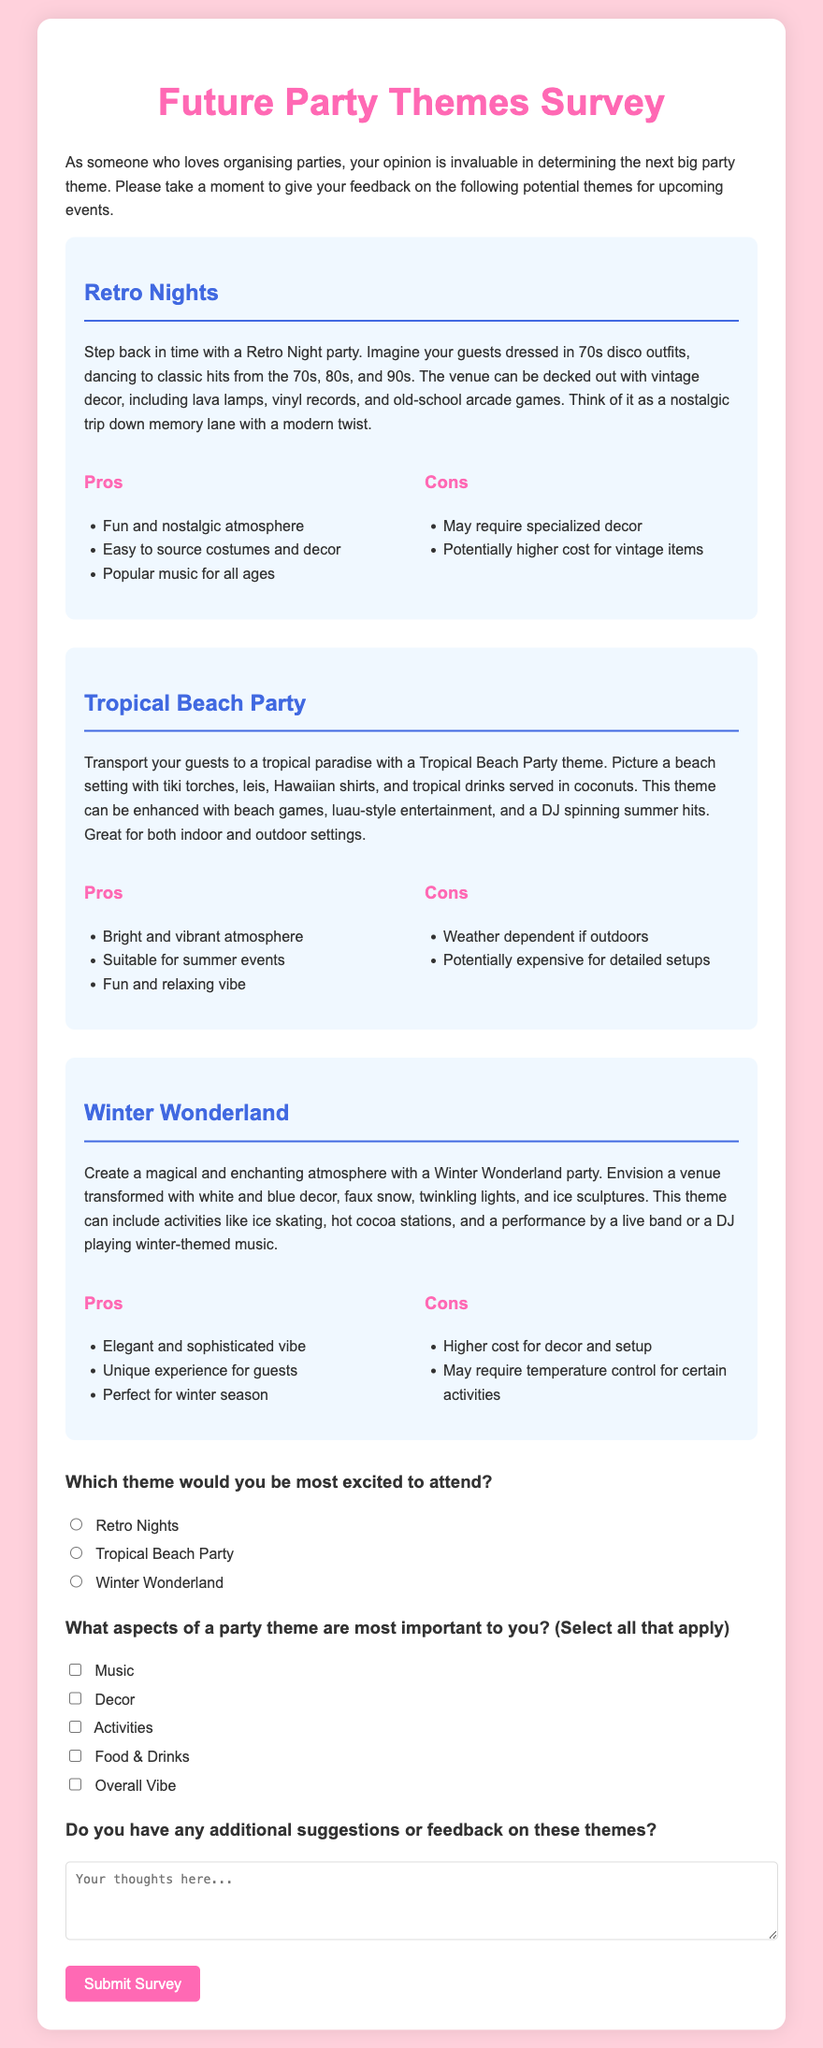What is the title of the survey? The title of the survey is the main heading displayed at the top of the document.
Answer: Future Party Themes Survey What is the background color of the page? The background color is specified in the body style of the document.
Answer: #ffd1dc How many party themes are described in the survey? The number of themes is determined by counting the individual theme sections provided in the document.
Answer: 3 What is one pro of the Retro Nights theme? Pros are listed in a section under the Retro Nights description; one example can be directly quoted.
Answer: Fun and nostalgic atmosphere What color is used for the headers of the pros and cons sections? The color of the headers is specified in the CSS rules for those elements in the document.
Answer: #ff69b4 What activity is suggested for the Winter Wonderland theme? The activities are outlined in the description of the Winter Wonderland theme.
Answer: Ice skating What is the first question in the survey form? The survey form begins with a specific question that prompts the user to choose a theme.
Answer: Which theme would you be most excited to attend? How many aspects can a respondent select in the "What aspects of a party theme are most important to you?" question? This is indicated by the number of options provided under that question in the document.
Answer: 5 What color is used for the theme backgrounds? The background color for the theme sections is specified in the CSS styling for those classes.
Answer: #f0f8ff What type of input is used for suggestions in the survey? The type of input provided for suggestions is specified under the respective question.
Answer: Textarea 